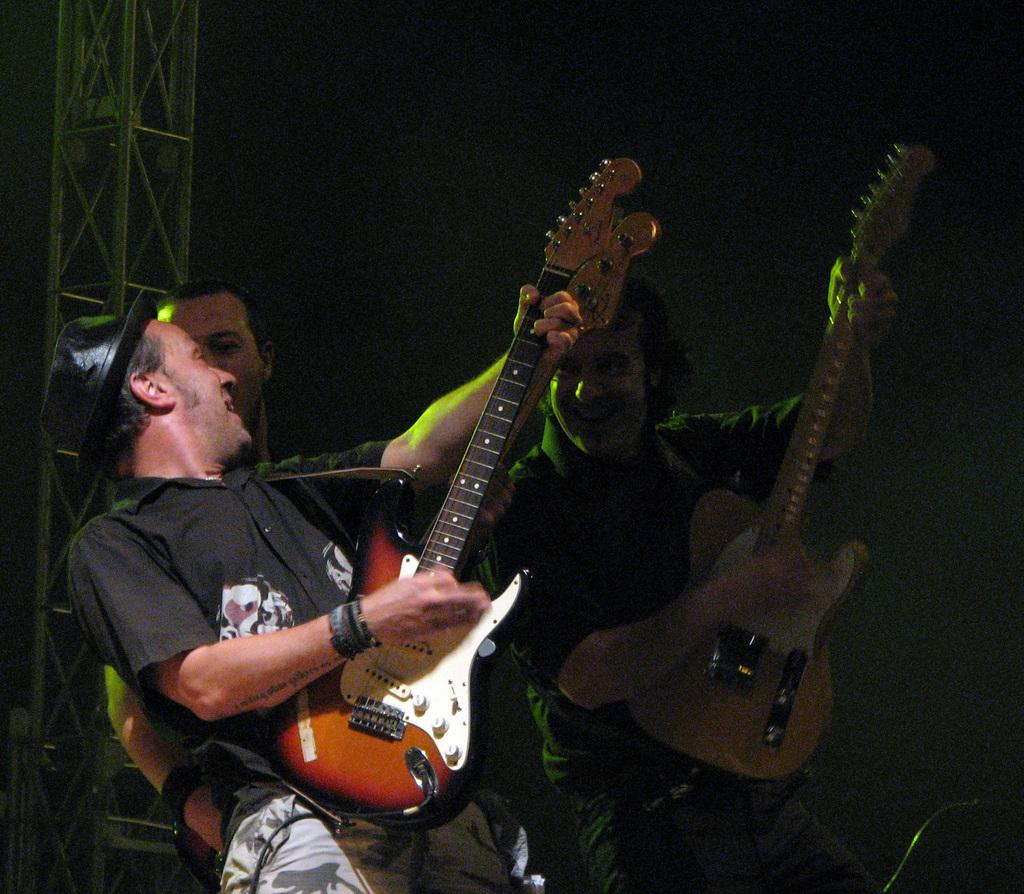Who or what is the main focus of the image? The main focus of the image is people playing guitars. Where are the guitars located in the image? The guitars are at the center of the image. What can be seen above the area where the people are playing guitars? There are spotlights above the area of the image. What type of grain is being harvested by the father in the image? There is no father or grain present in the image; it features people playing guitars with spotlights above them. How does the sail affect the performance of the musicians in the image? There is no sail present in the image; it only shows people playing guitars and spotlights above them. 